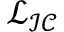Convert formula to latex. <formula><loc_0><loc_0><loc_500><loc_500>\mathcal { L } _ { \mathcal { I C } }</formula> 